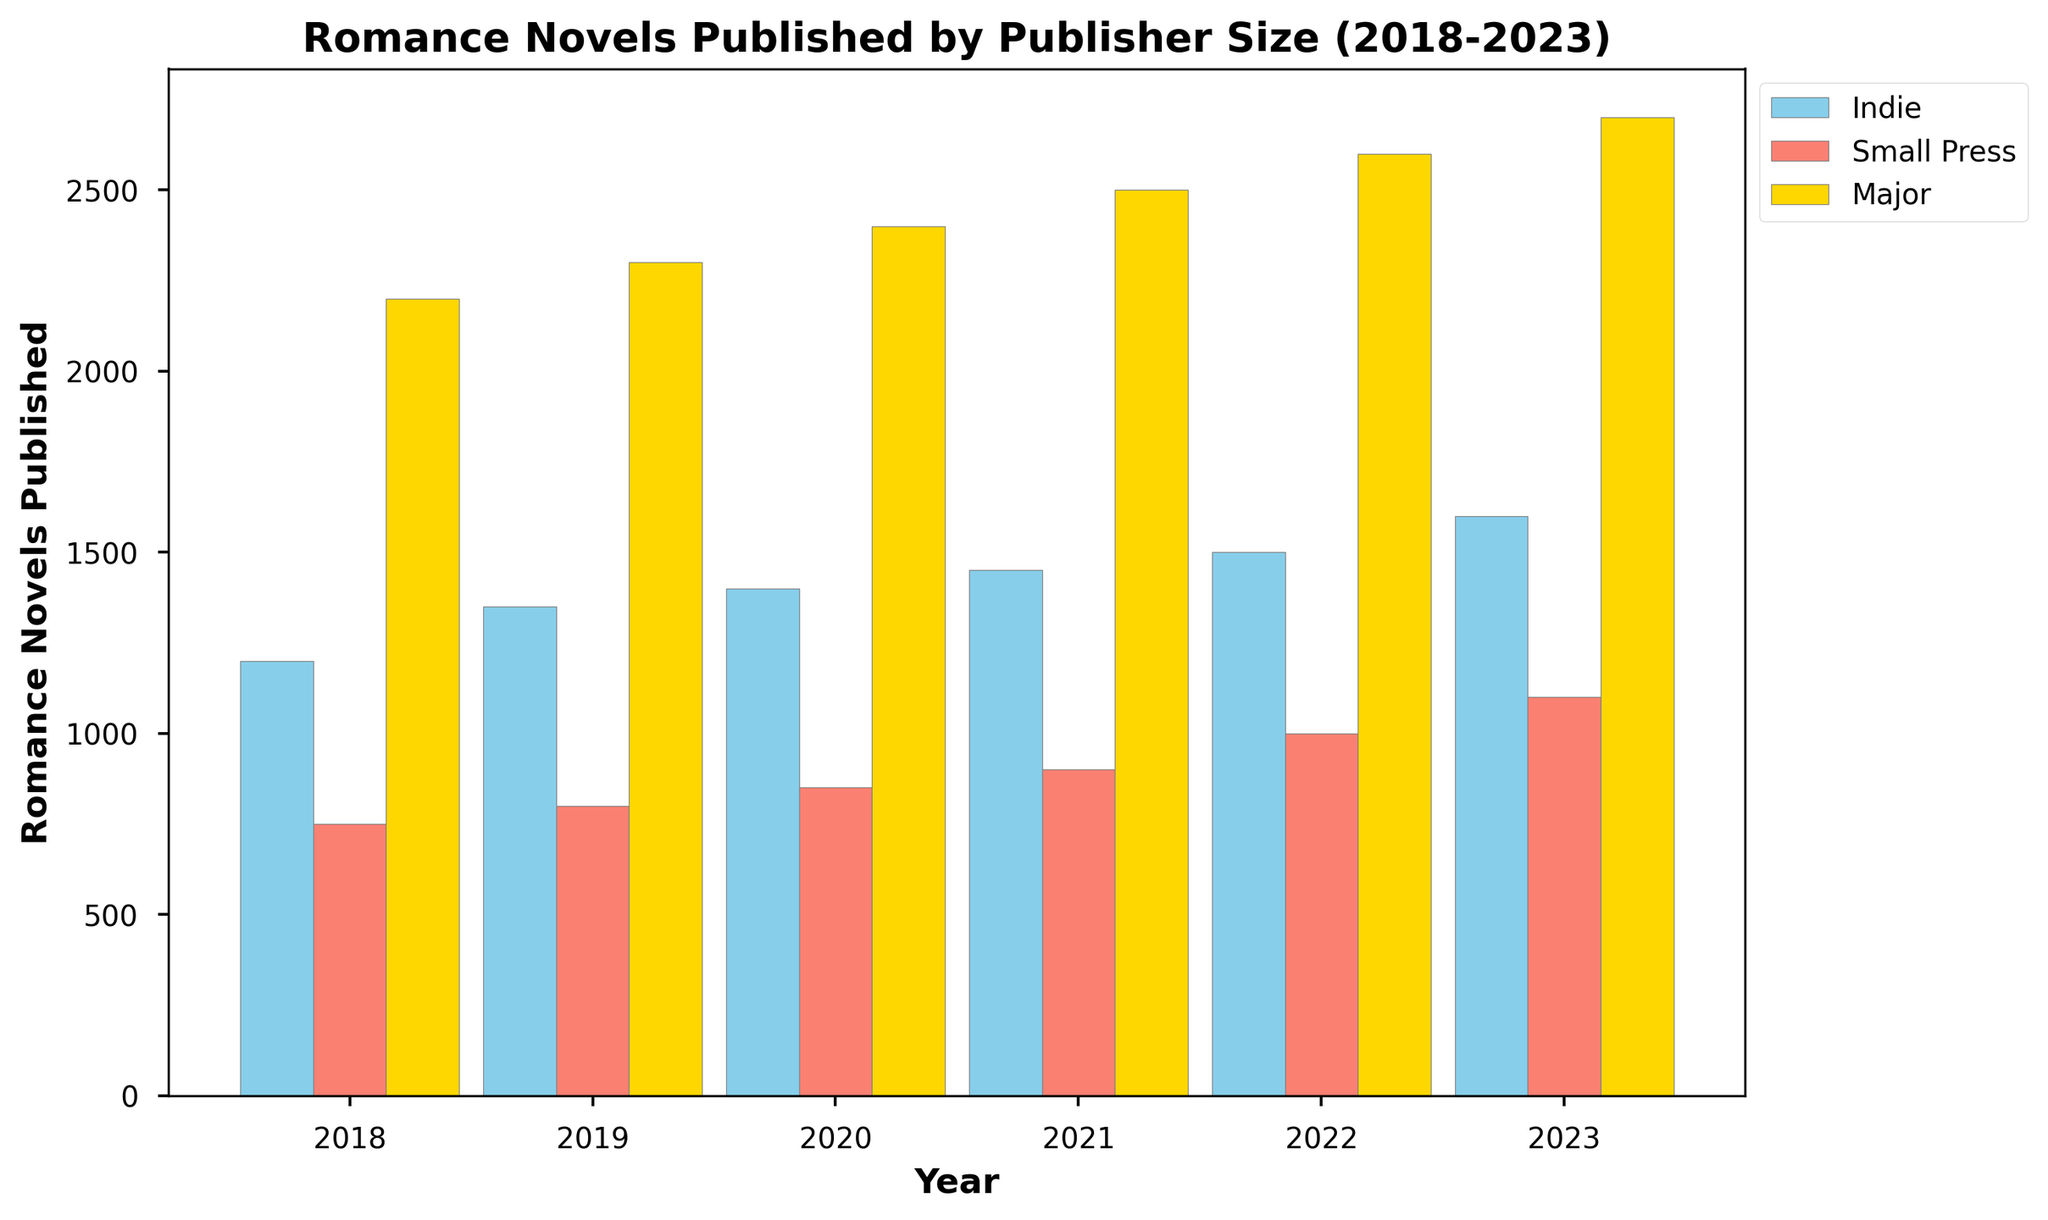What is the trend of romance novels published by indie publishers from 2018 to 2023? Observation shows that the number of romance novels published by indie publishers increased steadily from 1200 in 2018 to 1600 in 2023. The increase is consistent year over year.
Answer: Steady increase Which publisher size had the highest number of romance novels published in 2020? The major publishers had the highest number of romance novels published in 2020, with 2400 novels, compared to indie publishers (1400) and small press (850).
Answer: Major publishers How did the number of romance novels published by small press change from 2019 to 2023? The small press published 800 romance novels in 2019 and increased each year until 2023, reaching 1100 novels. The increase was gradual.
Answer: Gradual increase In which year did all publisher sizes together publish the most romance novels? By summing the numbers for each publisher size across the years: 2018 (4150), 2019 (4450), 2020 (4650), 2021 (4850), 2022 (5100), and 2023 (5400). 2023 has the highest total.
Answer: 2023 How many more romance novels did major publishers publish compared to indie publishers in 2021? Major publishers published 2500 novels, and indie publishers published 1450 novels in 2021. The difference is 2500 - 1450 = 1050.
Answer: 1050 What colors represent indie, small press, and major publishers in the plot? Indie publishers are represented by sky blue, small press by salmon, and major publishers by gold bars in the plot.
Answer: Sky blue (Indie), Salmon (Small press), Gold (Major) What is the average number of romance novels published per year by small press publishers between 2018 to 2023? Sum the novels published by small press (750, 800, 850, 900, 1000, 1100), which equals 5400, and divide by 6 years. 5400 / 6 = 900 novels/year on average.
Answer: 900 Which year saw the biggest increase in publication numbers for indie publishers compared to the previous year? By comparing yearly increases: 2018 to 2019 (150), 2019 to 2020 (50), 2020 to 2021 (50), 2021 to 2022 (50), 2022 to 2023 (100). The biggest increase was from 2018 to 2019.
Answer: 2018 to 2019 Which publisher size showed the smallest overall increase in romance novels published from 2018 to 2023? Calculate the overall increase for each: Indie (1600-1200=400), Small press (1100-750=350), Major (2700-2200=500). The smallest increase is for small press publishers.
Answer: Small press (350) In which year did indie publishers publish more than small press publishers but less than major publishers? From the data, indie publishers published more than small press publishers and less than major publishers in every year from 2018 to 2023.
Answer: All years (2018-2023) 